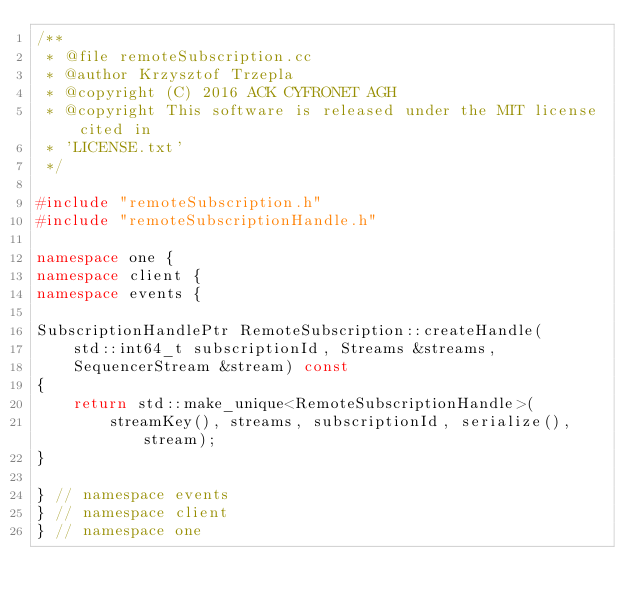<code> <loc_0><loc_0><loc_500><loc_500><_C++_>/**
 * @file remoteSubscription.cc
 * @author Krzysztof Trzepla
 * @copyright (C) 2016 ACK CYFRONET AGH
 * @copyright This software is released under the MIT license cited in
 * 'LICENSE.txt'
 */

#include "remoteSubscription.h"
#include "remoteSubscriptionHandle.h"

namespace one {
namespace client {
namespace events {

SubscriptionHandlePtr RemoteSubscription::createHandle(
    std::int64_t subscriptionId, Streams &streams,
    SequencerStream &stream) const
{
    return std::make_unique<RemoteSubscriptionHandle>(
        streamKey(), streams, subscriptionId, serialize(), stream);
}

} // namespace events
} // namespace client
} // namespace one
</code> 